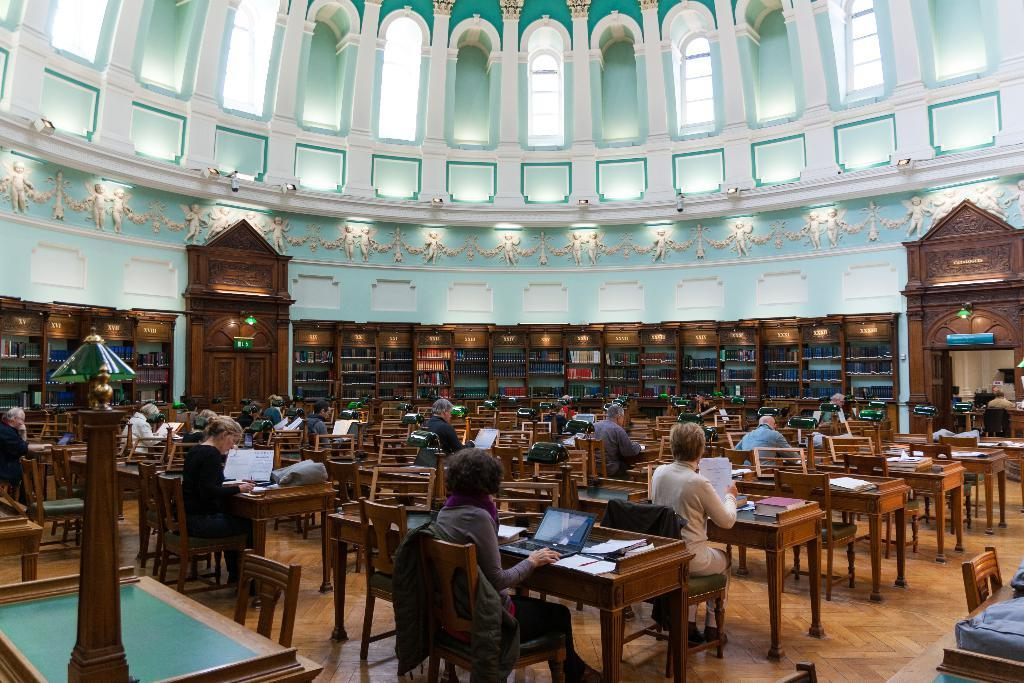What are the persons in the image doing? The persons in the image are sitting on chairs. What furniture is present in the image besides chairs? There are tables in the image. What objects can be seen on the tables? There is a laptop, paper, and a book on the tables. What can be seen in the background of the image? There is a wall in the background. What part of the room is visible? The floor is visible. Reasoning: Let's think step by step by step in order to produce the conversation. We start by identifying the main subjects and objects in the image based on the provided facts. We then formulate questions that focus on the actions and locations of these subjects and objects, ensuring that each question can be answered definitively with the information given. We avoid yes/no questions and ensure that the language is simple and clear. Absurd Question/Answer: Are there any crates visible in the image? No, there are no crates present in the image. Can you see any chickens in the image? No, there are no chickens present in the image. How many chickens are walking on the wall in the image? There are no chickens present in the image, and therefore no chickens can be seen walking on the wall. 